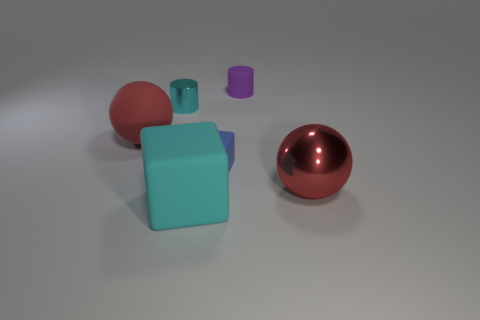Add 3 tiny green rubber spheres. How many objects exist? 9 Subtract all cubes. How many objects are left? 4 Add 5 large red rubber spheres. How many large red rubber spheres exist? 6 Subtract 0 gray cylinders. How many objects are left? 6 Subtract all tiny rubber things. Subtract all large matte cubes. How many objects are left? 3 Add 4 rubber cylinders. How many rubber cylinders are left? 5 